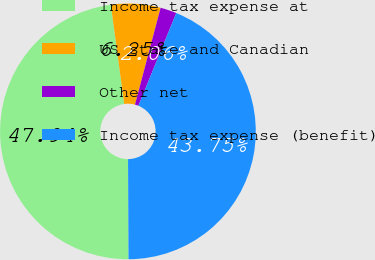Convert chart. <chart><loc_0><loc_0><loc_500><loc_500><pie_chart><fcel>Income tax expense at<fcel>US state and Canadian<fcel>Other net<fcel>Income tax expense (benefit)<nl><fcel>47.94%<fcel>6.25%<fcel>2.06%<fcel>43.75%<nl></chart> 